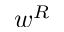<formula> <loc_0><loc_0><loc_500><loc_500>w ^ { R }</formula> 